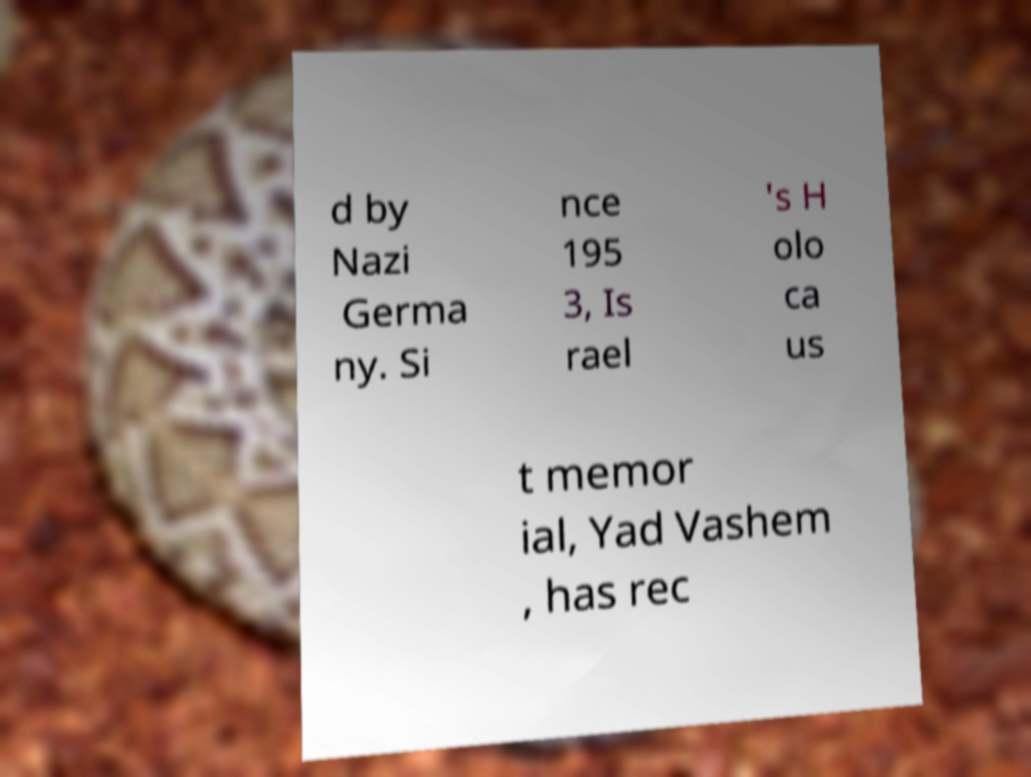Could you extract and type out the text from this image? d by Nazi Germa ny. Si nce 195 3, Is rael 's H olo ca us t memor ial, Yad Vashem , has rec 